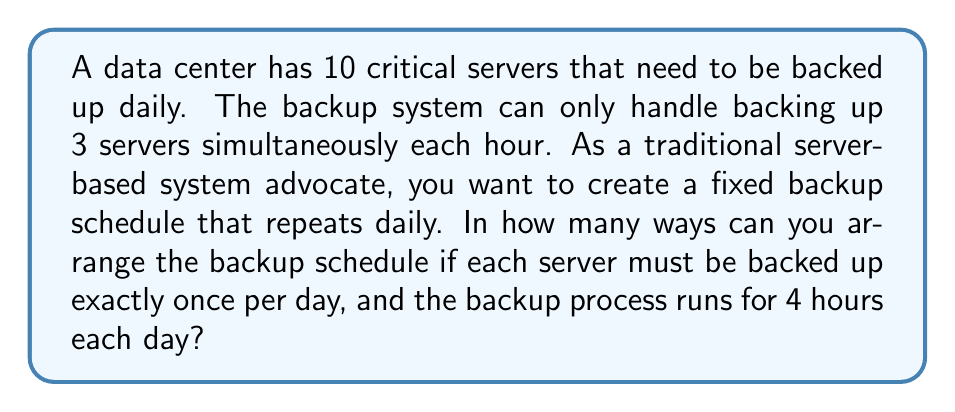Show me your answer to this math problem. Let's approach this step-by-step:

1) We need to distribute 10 servers across 4 time slots, with 3 servers in each slot.

2) This is a partition problem, specifically a distribution of 10 distinct objects (servers) into 4 distinct groups (time slots) of 3, 3, 3, and 1.

3) We can solve this using the multiplication principle:

   a) First, choose 3 servers for the first hour: $\binom{10}{3}$

   b) Then, choose 3 from the remaining 7 for the second hour: $\binom{7}{3}$

   c) Next, choose 3 from the remaining 4 for the third hour: $\binom{4}{3}$

   d) The last server automatically goes into the fourth hour.

4) Multiply these choices together:

   $$\binom{10}{3} \cdot \binom{7}{3} \cdot \binom{4}{3} = \frac{10!}{3!(10-3)!} \cdot \frac{7!}{3!(7-3)!} \cdot \frac{4!}{3!(4-3)!}$$

5) Simplify:

   $$\frac{10!}{3!7!} \cdot \frac{7!}{3!4!} \cdot \frac{4!}{3!1!} = \frac{10!}{(3!)^3 \cdot 4!}$$

6) Calculate:

   $$\frac{10 \cdot 9 \cdot 8 \cdot 7!}{6 \cdot 6 \cdot 6 \cdot 4 \cdot 3 \cdot 2 \cdot 1} = 4200$$

Therefore, there are 4200 possible ways to arrange the backup schedule.
Answer: 4200 